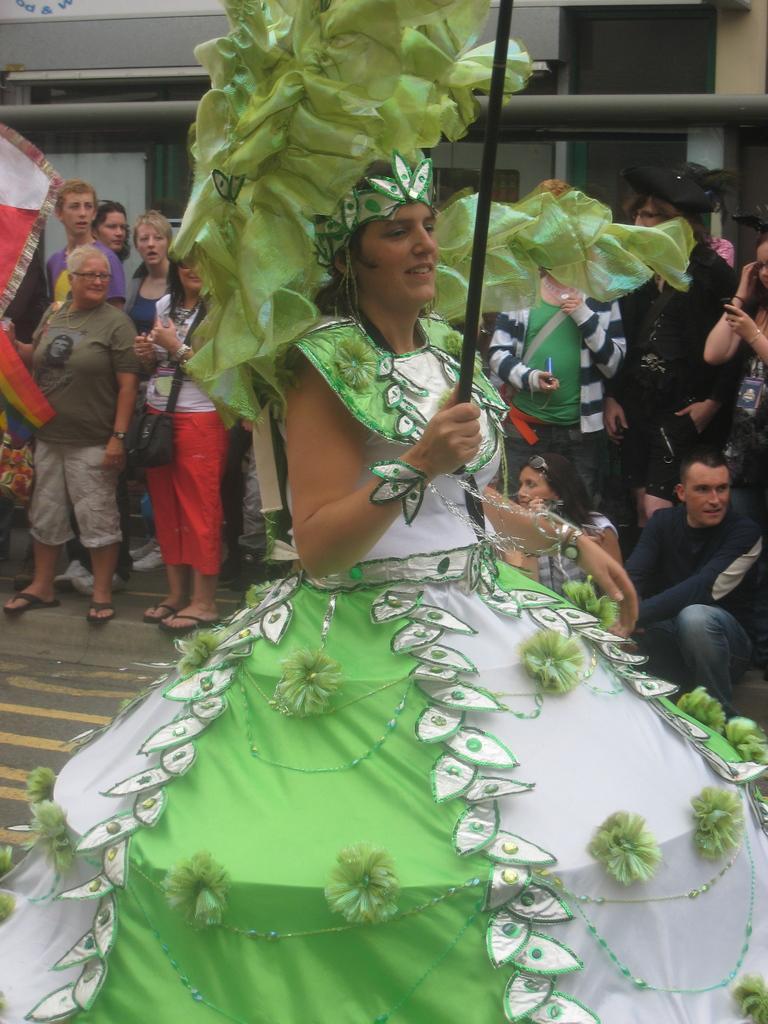In one or two sentences, can you explain what this image depicts? In the foreground of the picture there is a woman holding stick, she is wearing green and white frock. In the background there are people standing on the footpath. In the background there are buildings. 